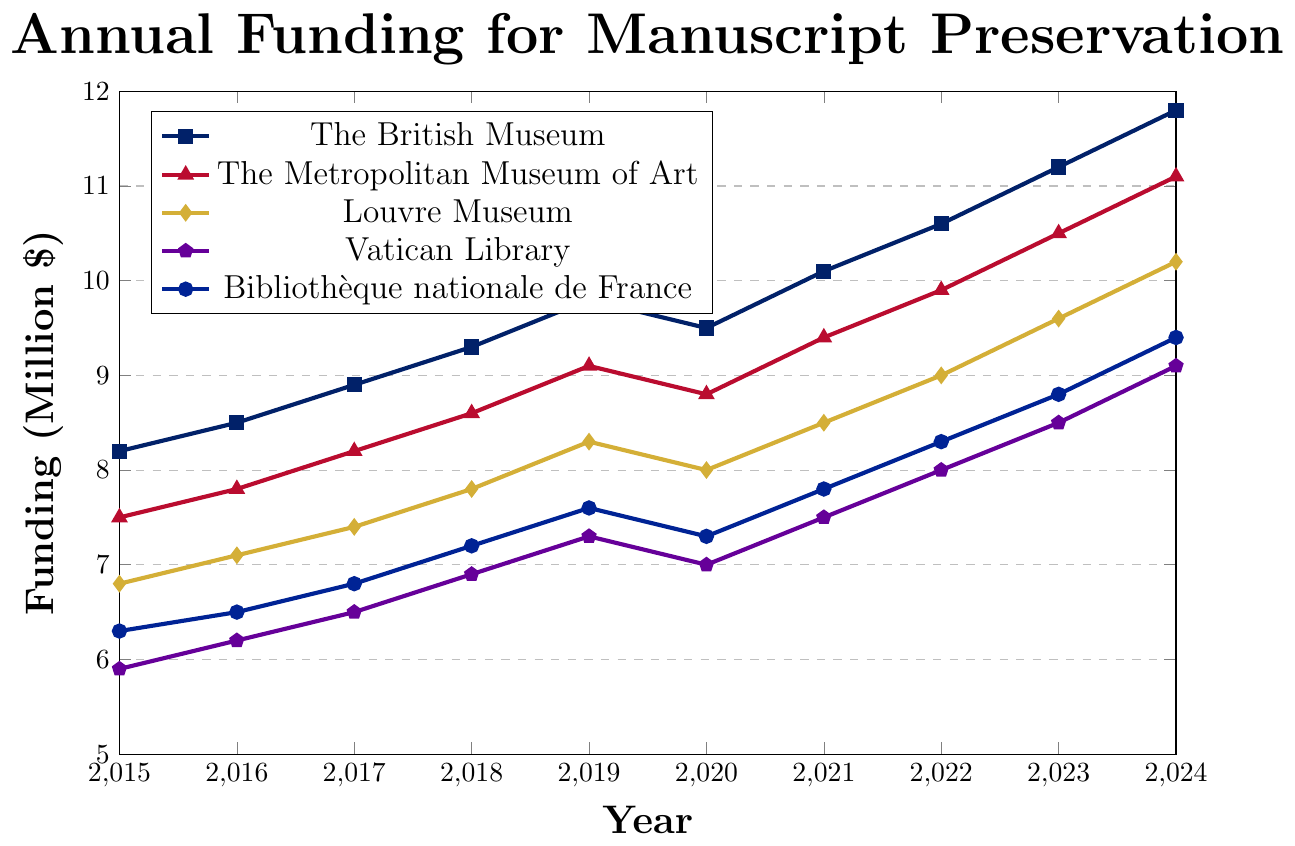What is the overall trend of funding for The British Museum from 2015 to 2024? To determine the trend, observe the general direction of the data points from 2015 to 2024. The funding for The British Museum increases from 8.2 million in 2015 to 11.8 million in 2024.
Answer: Increasing Which museum had the highest funding in 2023? Look at the funding values for each museum in 2023. The British Museum had 11.2 million, The Metropolitan Museum of Art had 10.5 million, the Louvre Museum had 9.6 million, the Vatican Library had 8.5 million, and the Bibliothèque nationale de France had 8.8 million.
Answer: The British Museum How much did the funding for the Bibliothèque nationale de France increase from 2015 to 2024? Subtract the funding in 2015 (6.3 million) from the funding in 2024 (9.4 million) for the Bibliothèque nationale de France. The difference is 9.4 - 6.3.
Answer: 3.1 million Which years did the Louvre Museum receive more funding than the Vatican Library? Compare the funding values for the Louvre Museum and the Vatican Library each year. The Louvre Museum received more funding than the Vatican Library in every year from 2015 to 2024.
Answer: 2015-2024 What is the average annual funding for The Metropolitan Museum of Art from 2018 to 2023? Sum the funding for The Metropolitan Museum of Art from 2018 to 2023, then divide by the number of years (6). The funding values are 8.6, 9.1, 8.8, 9.4, 9.9, and 10.5. Sum: 8.6 + 9.1 + 8.8 + 9.4 + 9.9 + 10.5 = 56.3 million. Average: 56.3 / 6.
Answer: 9.38 million In which year did The British Museum have the steepest annual increase in funding? Calculate the annual funding differences for The British Museum and find the maximum. Differences are 0.3, 0.4, 0.4, 0.5, -0.3, 0.6, 0.5, 0.6, and 0.6. The steepest increase is 0.6 in 2021, 2023, and 2024.
Answer: 2021, 2023, 2024 What is the total increase in funding for the Vatican Library from 2015 to 2024? Subtract the funding in 2015 (5.9 million) from the funding in 2024 (9.1 million) for the Vatican Library. The difference is 9.1 - 5.9.
Answer: 3.2 million Which museum had the lowest funding in 2017, and what was the amount? Check the funding values for each museum in 2017. The Vatican Library had the lowest funding in 2017 at 6.5 million.
Answer: The Vatican Library, 6.5 million Which museum showed a consistent increase in funding every year from 2015 to 2024? Analyze the trend for each museum. The British Museum, Louvre Museum, and Vatican Library all showed consistent increases except for the British Museum which decreased in 2020.
Answer: Louvre Museum 